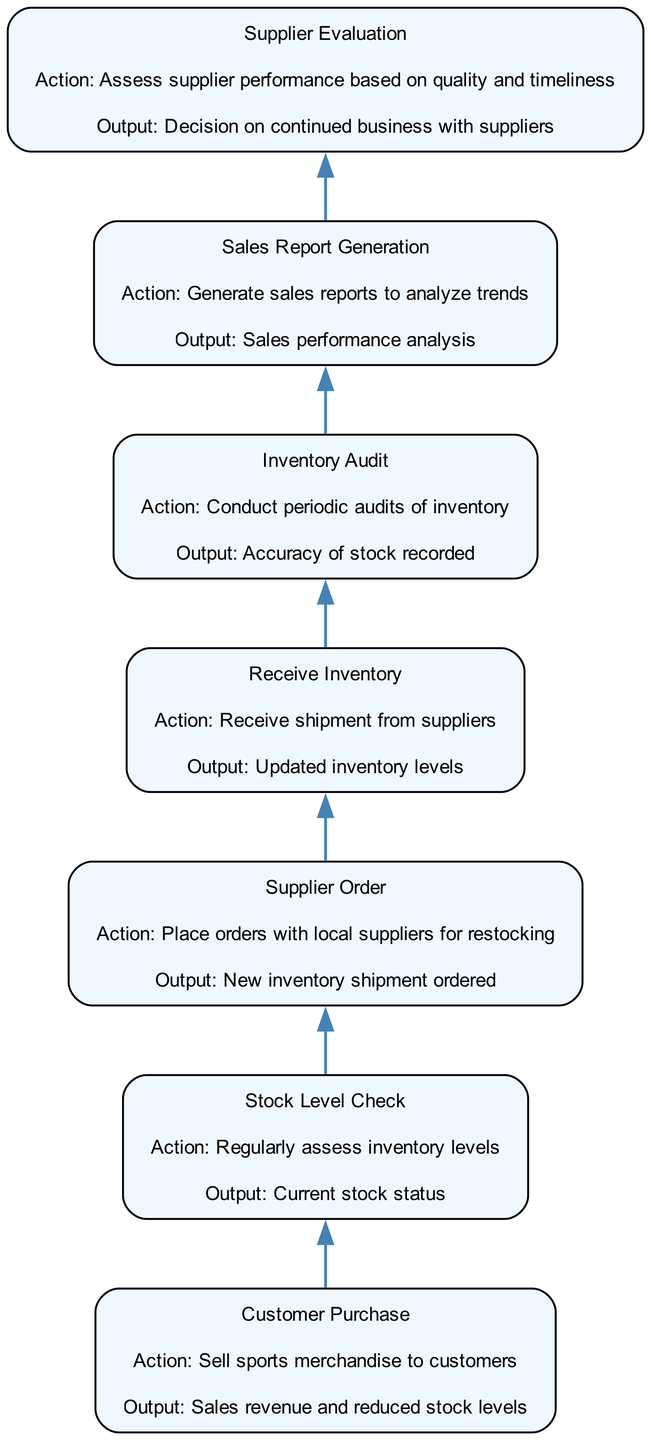What is the first step in the inventory management process? The first step is labeled as "Customer Purchase," which involves selling sports merchandise to customers. This is the starting point that initiates the entire process.
Answer: Customer Purchase How many nodes are present in the inventory management process? By counting the distinct stages represented in the diagram, we find a total of seven nodes: Customer Purchase, Stock Level Check, Supplier Order, Receive Inventory, Inventory Audit, Sales Report Generation, and Supplier Evaluation.
Answer: Seven What output is generated from conducting an Inventory Audit? According to the diagram, the output from conducting an Inventory Audit is stated as "Accuracy of stock recorded," indicating the results of this process stage.
Answer: Accuracy of stock recorded Which action follows the "Supplier Order"? The action that follows "Supplier Order" is "Receive Inventory," representing the next step in the process after placing orders with suppliers.
Answer: Receive Inventory What is the purpose of generating Sales Reports? The purpose of generating Sales Reports is to analyze trends, which is specified as the output from this action in the process. This indicates that data from sales is reviewed for insights.
Answer: Sales performance analysis If inventory is low, what action should be taken next? If inventory levels are low, the logical step indicated in the diagram is to "Supplier Order," where orders should be placed with suppliers for replenishing stock.
Answer: Supplier Order What connects the "Sales Report Generation" and "Supplier Evaluation"? The connecting action between "Sales Report Generation" and "Supplier Evaluation" is the output from the Sales Reports, which influences the evaluation of supplier performance, thus creating an interconnected decision-making process.
Answer: Sales performance analysis What occurs after "Receive Inventory"? After receiving inventory, the next step is to conduct an "Inventory Audit," ensuring all received items are accounted for and match the order provided by suppliers.
Answer: Inventory Audit What aspect is evaluated in the Supplier Evaluation step? In the Supplier Evaluation step, the performance of suppliers is assessed based on quality and timeliness, crucial for maintaining effective procurement processes.
Answer: Supplier performance based on quality and timeliness 